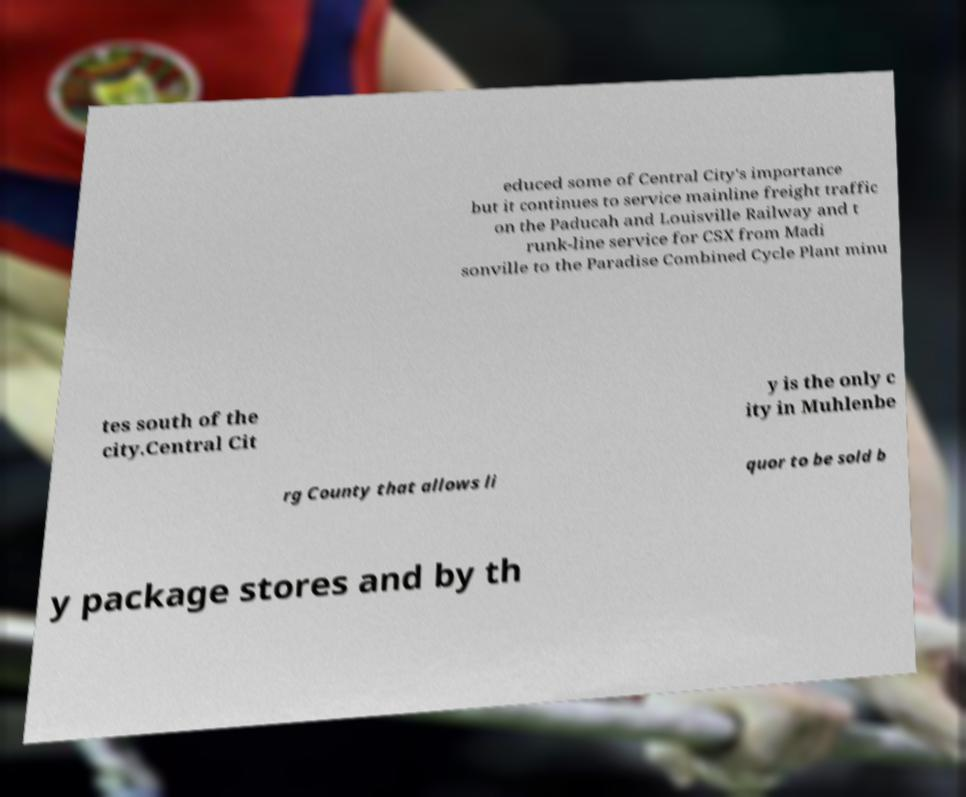Could you extract and type out the text from this image? educed some of Central City's importance but it continues to service mainline freight traffic on the Paducah and Louisville Railway and t runk-line service for CSX from Madi sonville to the Paradise Combined Cycle Plant minu tes south of the city.Central Cit y is the only c ity in Muhlenbe rg County that allows li quor to be sold b y package stores and by th 